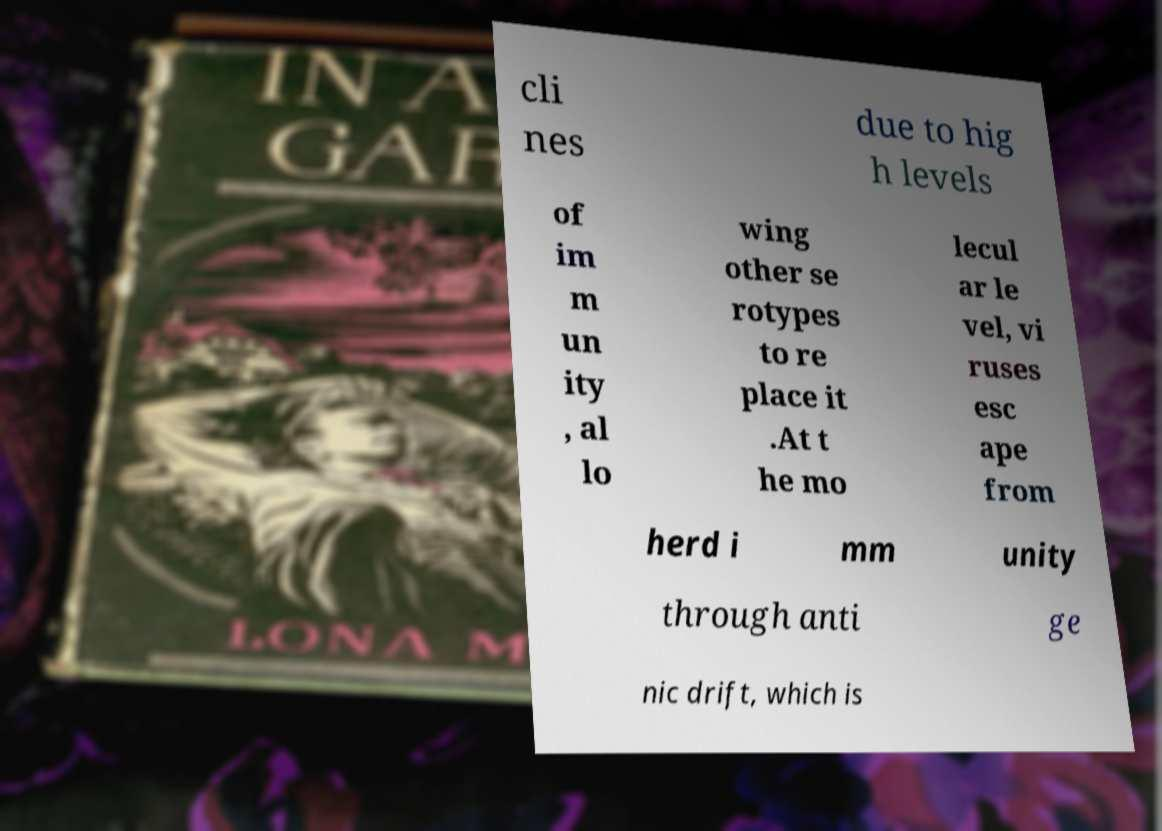Can you read and provide the text displayed in the image?This photo seems to have some interesting text. Can you extract and type it out for me? cli nes due to hig h levels of im m un ity , al lo wing other se rotypes to re place it .At t he mo lecul ar le vel, vi ruses esc ape from herd i mm unity through anti ge nic drift, which is 